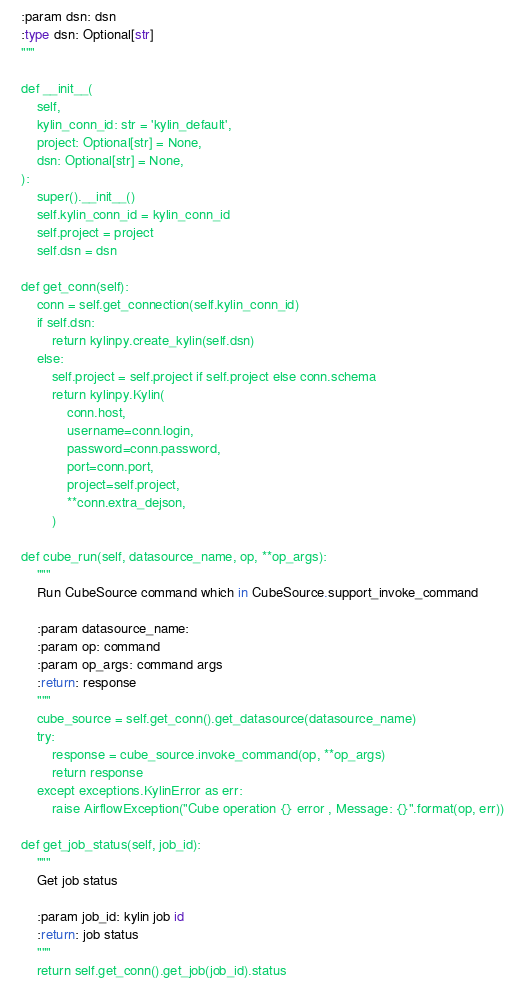Convert code to text. <code><loc_0><loc_0><loc_500><loc_500><_Python_>    :param dsn: dsn
    :type dsn: Optional[str]
    """

    def __init__(
        self,
        kylin_conn_id: str = 'kylin_default',
        project: Optional[str] = None,
        dsn: Optional[str] = None,
    ):
        super().__init__()
        self.kylin_conn_id = kylin_conn_id
        self.project = project
        self.dsn = dsn

    def get_conn(self):
        conn = self.get_connection(self.kylin_conn_id)
        if self.dsn:
            return kylinpy.create_kylin(self.dsn)
        else:
            self.project = self.project if self.project else conn.schema
            return kylinpy.Kylin(
                conn.host,
                username=conn.login,
                password=conn.password,
                port=conn.port,
                project=self.project,
                **conn.extra_dejson,
            )

    def cube_run(self, datasource_name, op, **op_args):
        """
        Run CubeSource command which in CubeSource.support_invoke_command

        :param datasource_name:
        :param op: command
        :param op_args: command args
        :return: response
        """
        cube_source = self.get_conn().get_datasource(datasource_name)
        try:
            response = cube_source.invoke_command(op, **op_args)
            return response
        except exceptions.KylinError as err:
            raise AirflowException("Cube operation {} error , Message: {}".format(op, err))

    def get_job_status(self, job_id):
        """
        Get job status

        :param job_id: kylin job id
        :return: job status
        """
        return self.get_conn().get_job(job_id).status
</code> 